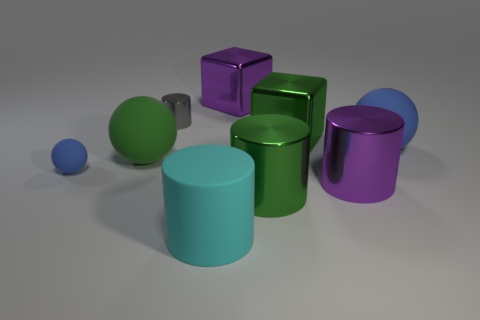This setup seems ordered in a specific way; can you tell what the arrangement suggests about the sizes of the objects? Certainly, the objects are arranged in a manner that suggests a progression of sizes and forms. On the left, you have the smallest object, a sphere, leading up to larger, more complex shapes like cubes and cylinders, all the way to the right. This ascending order from smaller to larger elements might hint at a deliberate showcasing of different geometries and volumes. 